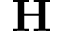<formula> <loc_0><loc_0><loc_500><loc_500>H</formula> 